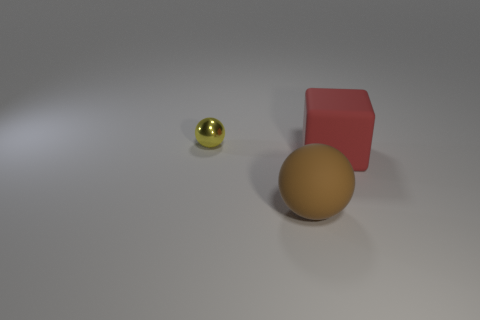What number of other things are there of the same size as the yellow ball?
Make the answer very short. 0. What is the large thing that is in front of the big thing on the right side of the rubber object that is in front of the cube made of?
Provide a succinct answer. Rubber. Does the large ball have the same material as the sphere left of the large ball?
Your answer should be very brief. No. Is the number of rubber cubes on the left side of the large red object less than the number of spheres that are right of the shiny thing?
Offer a very short reply. Yes. What number of yellow objects have the same material as the cube?
Offer a terse response. 0. Is there a rubber thing in front of the thing to the left of the ball to the right of the small metal object?
Provide a succinct answer. Yes. What number of blocks are red matte things or large gray rubber things?
Your answer should be very brief. 1. There is a red object; does it have the same shape as the big rubber thing that is in front of the red matte object?
Make the answer very short. No. Is the number of objects that are behind the metallic ball less than the number of tiny metallic objects?
Offer a terse response. Yes. Are there any big objects on the left side of the large red object?
Offer a very short reply. Yes. 